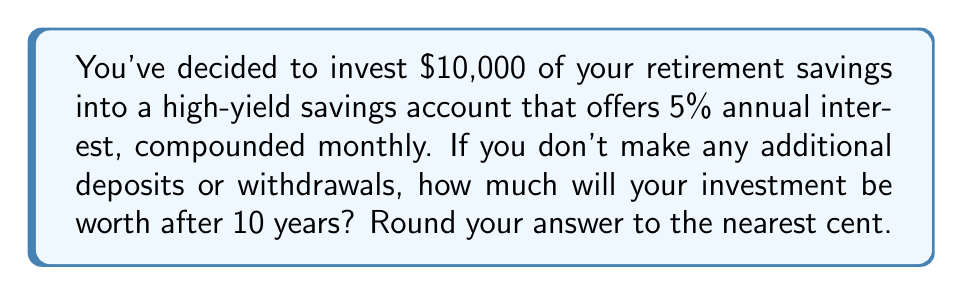Solve this math problem. To solve this problem, we'll use the compound interest formula:

$$A = P(1 + \frac{r}{n})^{nt}$$

Where:
$A$ = the final amount
$P$ = the principal (initial investment)
$r$ = the annual interest rate (as a decimal)
$n$ = the number of times interest is compounded per year
$t$ = the time in years

Given:
$P = 10000$
$r = 0.05$ (5% expressed as a decimal)
$n = 12$ (compounded monthly)
$t = 10$ years

Let's plug these values into the formula:

$$A = 10000(1 + \frac{0.05}{12})^{12 * 10}$$

$$A = 10000(1 + 0.004167)^{120}$$

$$A = 10000(1.004167)^{120}$$

Using a calculator or spreadsheet to compute this:

$$A = 10000 * 1.6470$$

$$A = 16470.09$$

Rounding to the nearest cent:

$$A = 16470.09$$
Answer: $16,470.09 